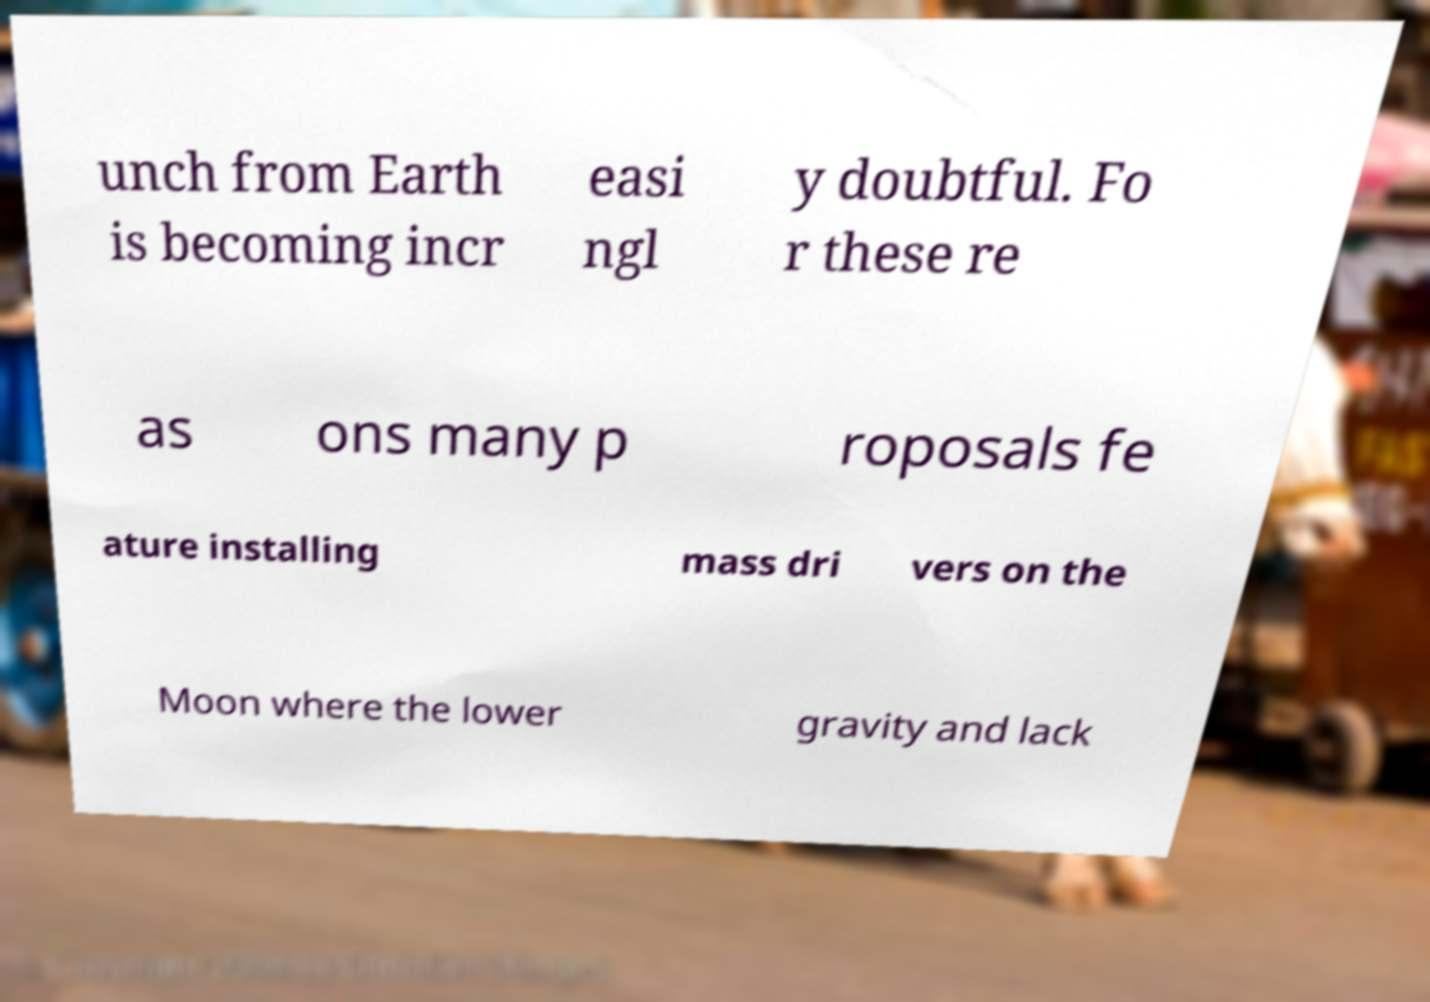There's text embedded in this image that I need extracted. Can you transcribe it verbatim? unch from Earth is becoming incr easi ngl y doubtful. Fo r these re as ons many p roposals fe ature installing mass dri vers on the Moon where the lower gravity and lack 